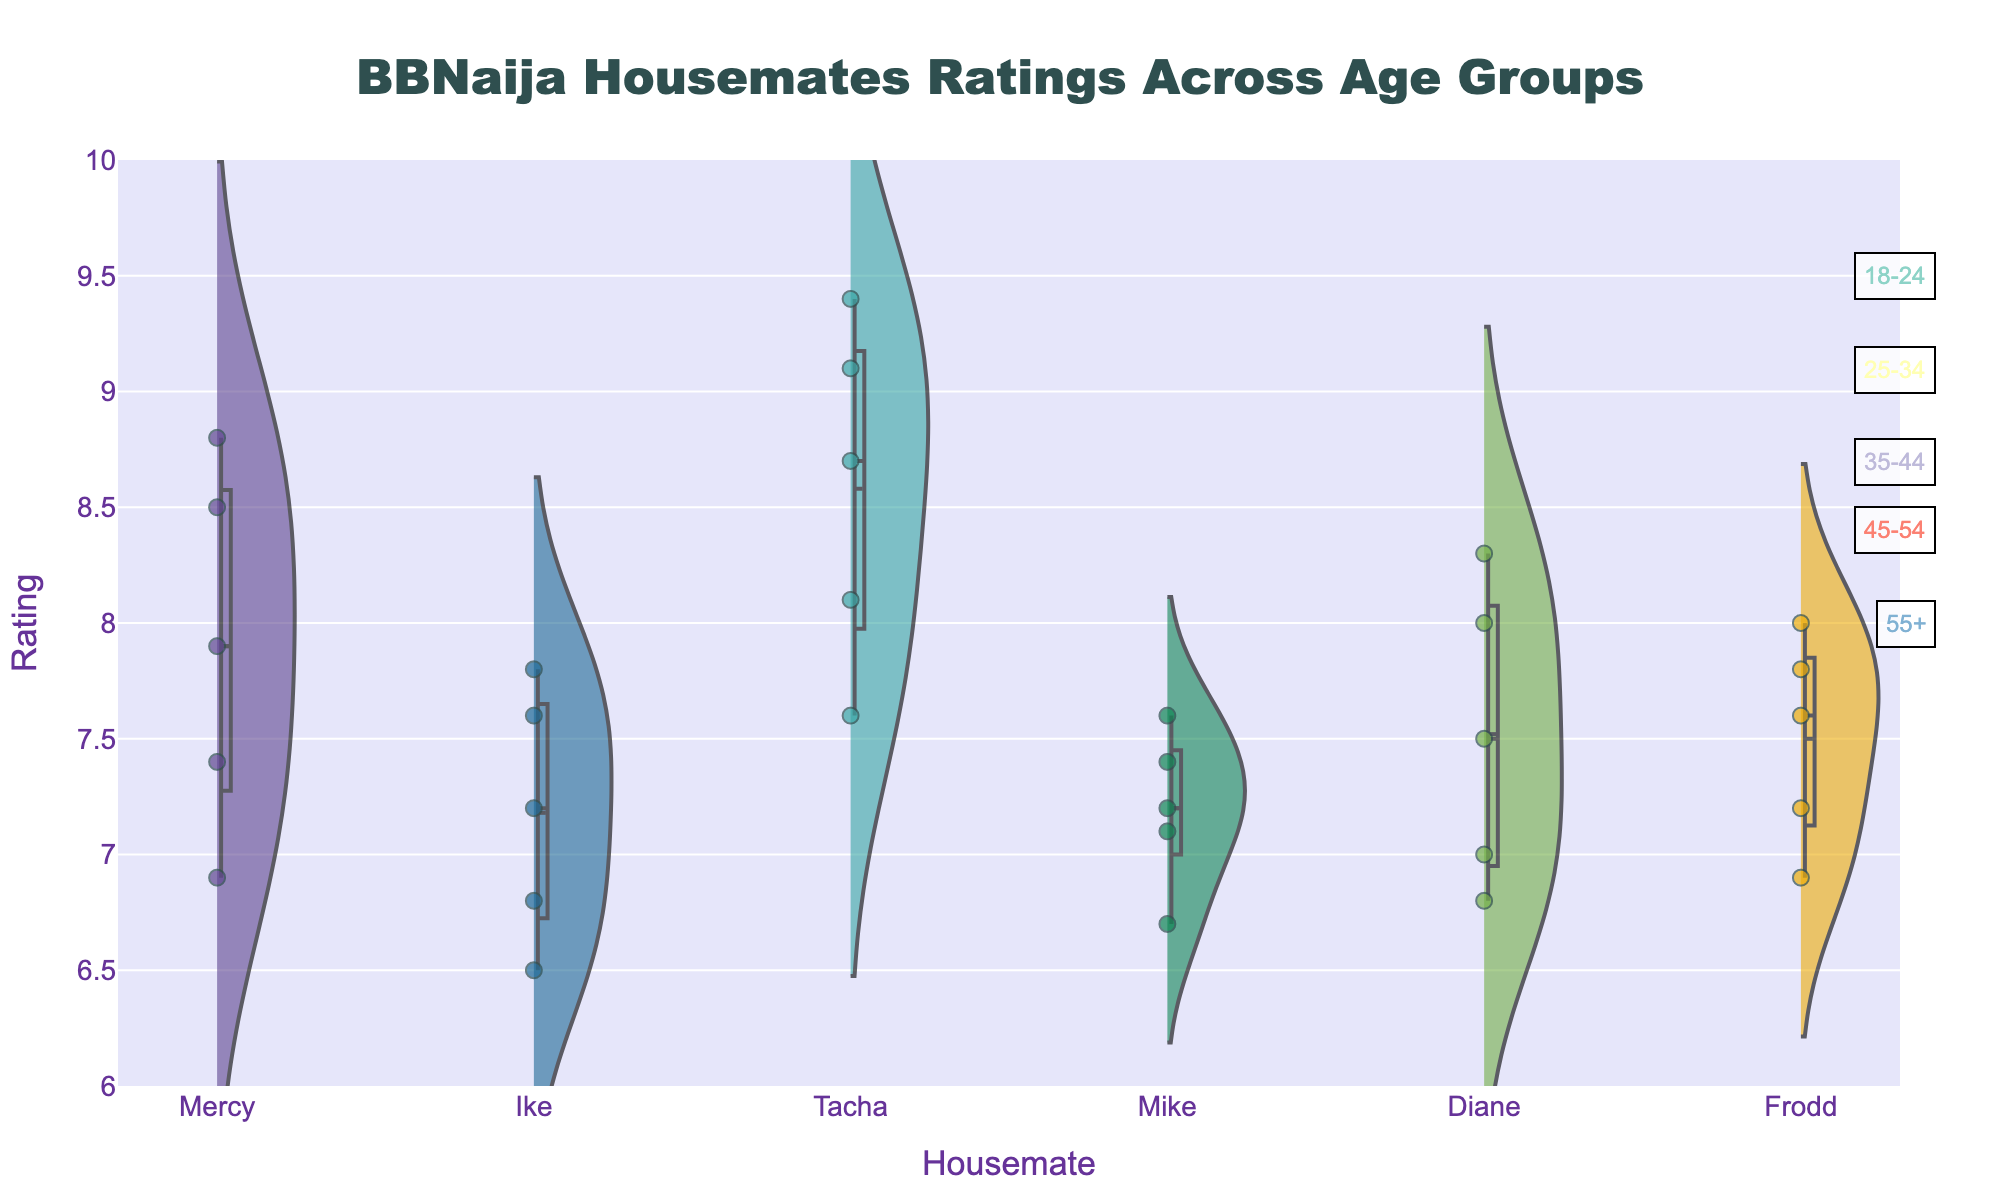What is the title of the figure? The title of the figure is typically prominently displayed at the top of the plot. Here, it reads, "BBNaija Housemates Ratings Across Age Groups."
Answer: BBNaija Housemates Ratings Across Age Groups Which housemate has the highest rating across any age group? To determine this, locate the highest point on the y-axis for each housemate. The tallest peak belongs to Tacha in the 25-34 age group.
Answer: Tacha What is the average rating for Mercy? To find the average, sum up Mercy's ratings across all age groups: 8.5 + 8.8 + 7.9 + 7.4 + 6.9 = 39.5. Then, divide by the number of age groups, 39.5/5 = 7.9
Answer: 7.9 Who has a higher rating in the 35-44 age group, Frodd or Mike? Compare the ratings of Frodd and Mike in the 35-44 age group. Frodd's rating is 8.0, and Mike's rating is 7.6. Frodd’s rating is higher.
Answer: Frodd Which housemate shows the largest decline in ratings from the 18-24 age group to the 55+ age group? Calculate the differences for each housemate's rating between the 18-24 and 55+ age groups. The housemate with the largest decline is the one with the biggest difference. Tacha's rating drops from 9.1 to 7.6, a decline of 1.5, which is the largest.
Answer: Tacha How do the individual ratings of Diane compare to the overall trend of other housemates? Assess Diane's ratings (8.3, 8.0, 7.5, 7.0, 6.8). Generally, her ratings follow a downward trend, similar to the overall trend observed for other housemates as age increases.
Answer: Similar downward trend What pattern can be observed for the meanline in the violin plot? The meanline represents the average rating for each housemate. These meanlines are visibly straight and align more towards the higher end for housemates like Tacha, indicating higher ratings, whereas they are more towards the lower end for housemates like Ike.
Answer: Higher for Tacha, lower for Ike Which age group contributes most to Frodd’s average rating? By observing the points and mean line for Frodd, the 35-44 age group has the highest rating at 8.0, which significantly contributes to raising his average.
Answer: 35-44 Are there any outliers in the ratings of housemates? Violins and jittered points indicate data distribution and spread. There doesn't appear to be points significantly detached from the distributions in each plot, indicating no outliers.
Answer: No 